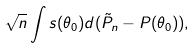<formula> <loc_0><loc_0><loc_500><loc_500>\sqrt { n } \int s ( \theta _ { 0 } ) d ( \tilde { P } _ { n } - P ( \theta _ { 0 } ) ) ,</formula> 